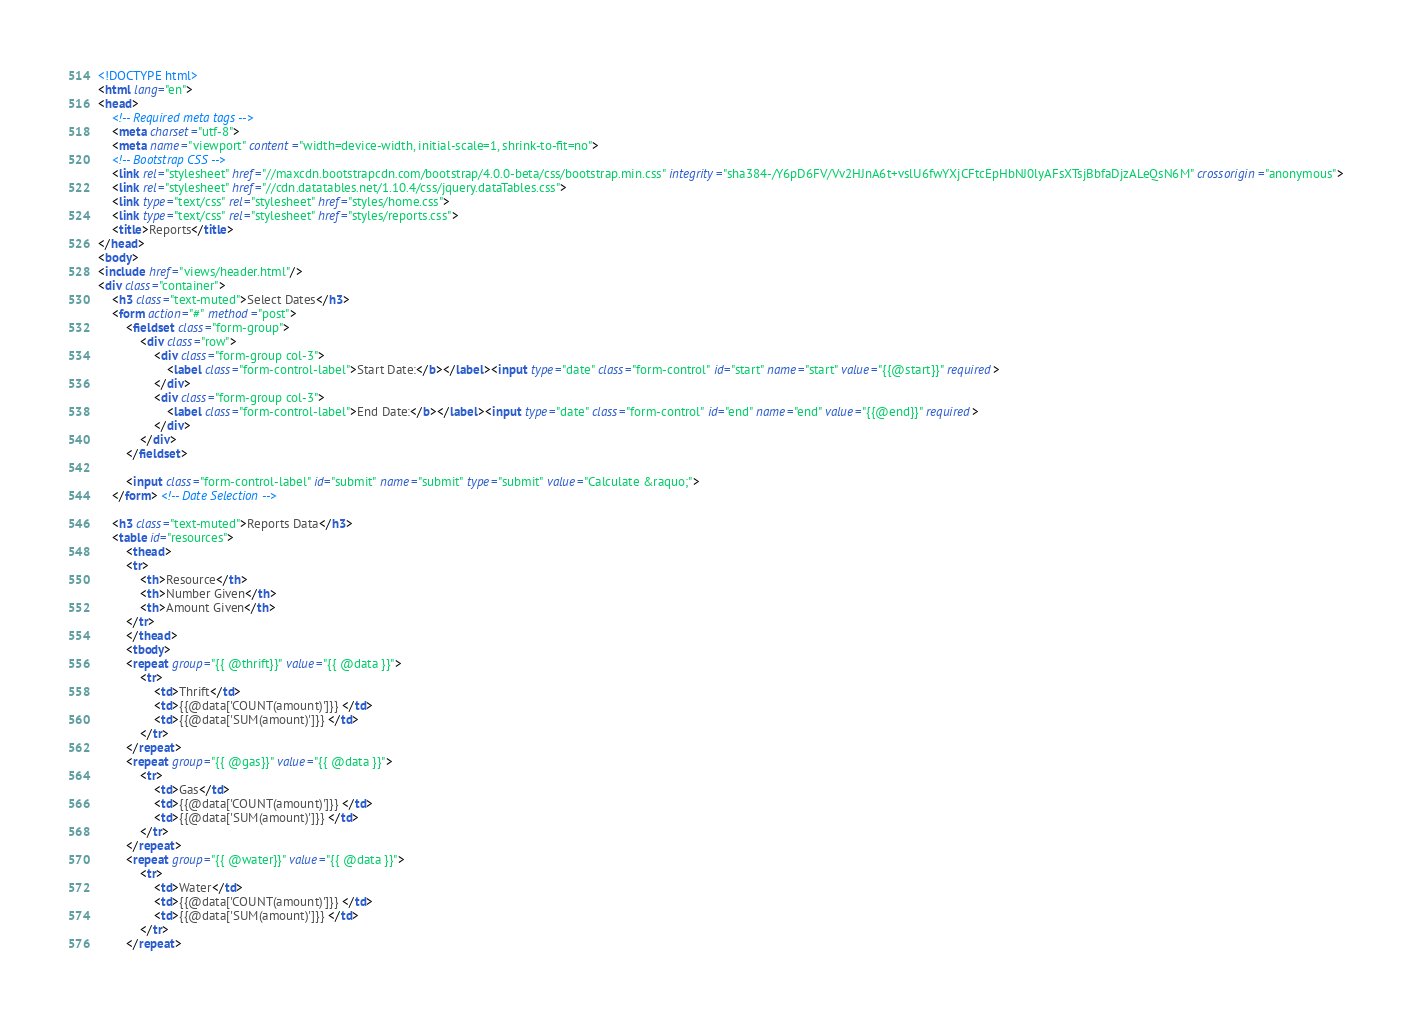<code> <loc_0><loc_0><loc_500><loc_500><_HTML_><!DOCTYPE html>
<html lang="en">
<head>
    <!-- Required meta tags -->
    <meta charset="utf-8">
    <meta name="viewport" content="width=device-width, initial-scale=1, shrink-to-fit=no">
    <!-- Bootstrap CSS -->
    <link rel="stylesheet" href="//maxcdn.bootstrapcdn.com/bootstrap/4.0.0-beta/css/bootstrap.min.css" integrity="sha384-/Y6pD6FV/Vv2HJnA6t+vslU6fwYXjCFtcEpHbNJ0lyAFsXTsjBbfaDjzALeQsN6M" crossorigin="anonymous">
    <link rel="stylesheet" href="//cdn.datatables.net/1.10.4/css/jquery.dataTables.css">
    <link type="text/css" rel="stylesheet" href="styles/home.css">
    <link type="text/css" rel="stylesheet" href="styles/reports.css">
    <title>Reports</title>
</head>
<body>
<include href="views/header.html"/>
<div class="container">
    <h3 class="text-muted">Select Dates</h3>
    <form action="#" method="post">
        <fieldset class="form-group">
            <div class="row">
                <div class="form-group col-3">
                    <label class="form-control-label">Start Date:</b></label><input type="date" class="form-control" id="start" name="start" value="{{@start}}" required>
                </div>
                <div class="form-group col-3">
                    <label class="form-control-label">End Date:</b></label><input type="date" class="form-control" id="end" name="end" value="{{@end}}" required>
                </div>
            </div>
        </fieldset>

        <input class="form-control-label" id="submit" name="submit" type="submit" value="Calculate &raquo;">
    </form> <!-- Date Selection -->

    <h3 class="text-muted">Reports Data</h3>
    <table id="resources">
        <thead>
        <tr>
            <th>Resource</th>
            <th>Number Given</th>
            <th>Amount Given</th>
        </tr>
        </thead>
        <tbody>
        <repeat group="{{ @thrift}}" value="{{ @data }}">
            <tr>
                <td>Thrift</td>
                <td>{{@data['COUNT(amount)']}} </td>
                <td>{{@data['SUM(amount)']}} </td>
            </tr>
        </repeat>
        <repeat group="{{ @gas}}" value="{{ @data }}">
            <tr>
                <td>Gas</td>
                <td>{{@data['COUNT(amount)']}} </td>
                <td>{{@data['SUM(amount)']}} </td>
            </tr>
        </repeat>
        <repeat group="{{ @water}}" value="{{ @data }}">
            <tr>
                <td>Water</td>
                <td>{{@data['COUNT(amount)']}} </td>
                <td>{{@data['SUM(amount)']}} </td>
            </tr>
        </repeat></code> 